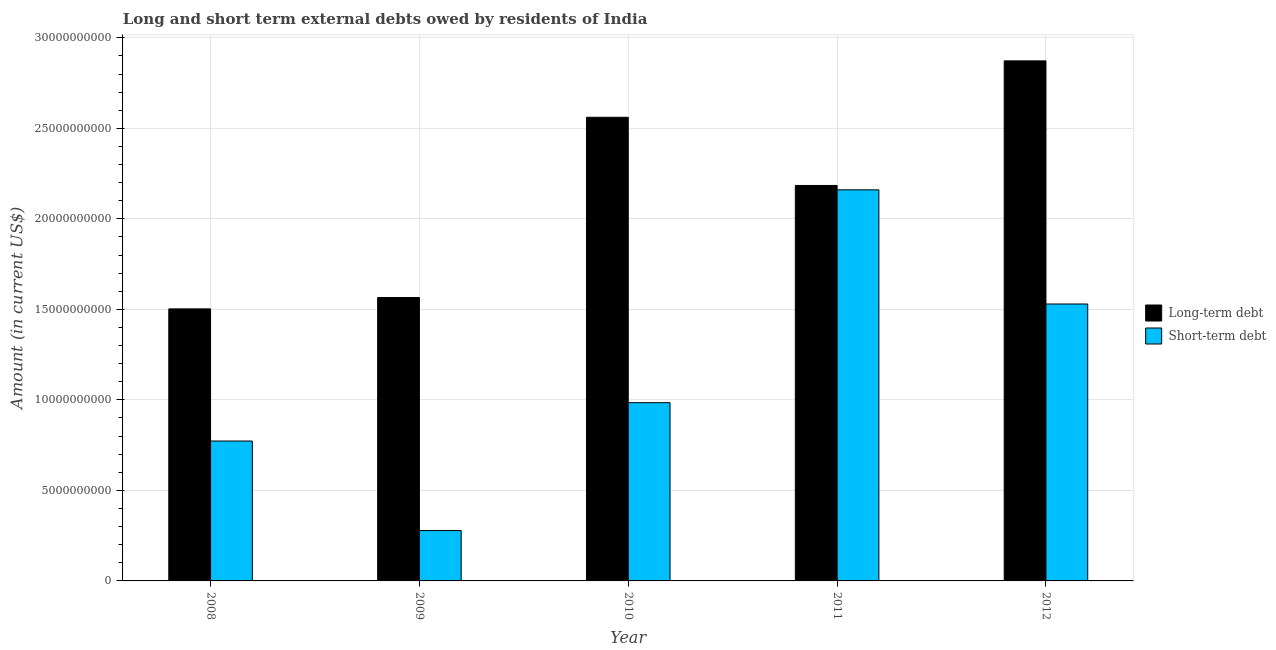How many groups of bars are there?
Your answer should be compact. 5. Are the number of bars on each tick of the X-axis equal?
Provide a short and direct response. Yes. How many bars are there on the 4th tick from the left?
Your response must be concise. 2. What is the label of the 2nd group of bars from the left?
Give a very brief answer. 2009. What is the long-term debts owed by residents in 2012?
Ensure brevity in your answer.  2.87e+1. Across all years, what is the maximum short-term debts owed by residents?
Your answer should be compact. 2.16e+1. Across all years, what is the minimum short-term debts owed by residents?
Your answer should be compact. 2.78e+09. What is the total short-term debts owed by residents in the graph?
Your response must be concise. 5.73e+1. What is the difference between the short-term debts owed by residents in 2008 and that in 2009?
Provide a succinct answer. 4.95e+09. What is the difference between the short-term debts owed by residents in 2011 and the long-term debts owed by residents in 2012?
Your response must be concise. 6.31e+09. What is the average short-term debts owed by residents per year?
Offer a terse response. 1.15e+1. What is the ratio of the short-term debts owed by residents in 2010 to that in 2012?
Keep it short and to the point. 0.64. Is the short-term debts owed by residents in 2009 less than that in 2012?
Your answer should be very brief. Yes. Is the difference between the short-term debts owed by residents in 2009 and 2010 greater than the difference between the long-term debts owed by residents in 2009 and 2010?
Offer a very short reply. No. What is the difference between the highest and the second highest long-term debts owed by residents?
Give a very brief answer. 3.12e+09. What is the difference between the highest and the lowest short-term debts owed by residents?
Ensure brevity in your answer.  1.88e+1. In how many years, is the long-term debts owed by residents greater than the average long-term debts owed by residents taken over all years?
Keep it short and to the point. 3. Is the sum of the short-term debts owed by residents in 2009 and 2010 greater than the maximum long-term debts owed by residents across all years?
Offer a very short reply. No. What does the 1st bar from the left in 2010 represents?
Give a very brief answer. Long-term debt. What does the 2nd bar from the right in 2010 represents?
Keep it short and to the point. Long-term debt. How many bars are there?
Your answer should be compact. 10. How many years are there in the graph?
Ensure brevity in your answer.  5. Where does the legend appear in the graph?
Your response must be concise. Center right. How many legend labels are there?
Ensure brevity in your answer.  2. What is the title of the graph?
Provide a succinct answer. Long and short term external debts owed by residents of India. What is the label or title of the X-axis?
Provide a short and direct response. Year. What is the Amount (in current US$) of Long-term debt in 2008?
Ensure brevity in your answer.  1.50e+1. What is the Amount (in current US$) of Short-term debt in 2008?
Your answer should be compact. 7.73e+09. What is the Amount (in current US$) of Long-term debt in 2009?
Offer a terse response. 1.57e+1. What is the Amount (in current US$) of Short-term debt in 2009?
Provide a succinct answer. 2.78e+09. What is the Amount (in current US$) in Long-term debt in 2010?
Your answer should be very brief. 2.56e+1. What is the Amount (in current US$) in Short-term debt in 2010?
Keep it short and to the point. 9.84e+09. What is the Amount (in current US$) in Long-term debt in 2011?
Keep it short and to the point. 2.18e+1. What is the Amount (in current US$) in Short-term debt in 2011?
Your response must be concise. 2.16e+1. What is the Amount (in current US$) of Long-term debt in 2012?
Give a very brief answer. 2.87e+1. What is the Amount (in current US$) of Short-term debt in 2012?
Your answer should be very brief. 1.53e+1. Across all years, what is the maximum Amount (in current US$) in Long-term debt?
Your response must be concise. 2.87e+1. Across all years, what is the maximum Amount (in current US$) of Short-term debt?
Provide a short and direct response. 2.16e+1. Across all years, what is the minimum Amount (in current US$) in Long-term debt?
Give a very brief answer. 1.50e+1. Across all years, what is the minimum Amount (in current US$) in Short-term debt?
Make the answer very short. 2.78e+09. What is the total Amount (in current US$) in Long-term debt in the graph?
Your response must be concise. 1.07e+11. What is the total Amount (in current US$) of Short-term debt in the graph?
Offer a terse response. 5.73e+1. What is the difference between the Amount (in current US$) in Long-term debt in 2008 and that in 2009?
Make the answer very short. -6.29e+08. What is the difference between the Amount (in current US$) of Short-term debt in 2008 and that in 2009?
Your answer should be compact. 4.95e+09. What is the difference between the Amount (in current US$) of Long-term debt in 2008 and that in 2010?
Ensure brevity in your answer.  -1.06e+1. What is the difference between the Amount (in current US$) in Short-term debt in 2008 and that in 2010?
Your response must be concise. -2.12e+09. What is the difference between the Amount (in current US$) in Long-term debt in 2008 and that in 2011?
Offer a very short reply. -6.82e+09. What is the difference between the Amount (in current US$) in Short-term debt in 2008 and that in 2011?
Your answer should be very brief. -1.39e+1. What is the difference between the Amount (in current US$) of Long-term debt in 2008 and that in 2012?
Offer a terse response. -1.37e+1. What is the difference between the Amount (in current US$) of Short-term debt in 2008 and that in 2012?
Give a very brief answer. -7.57e+09. What is the difference between the Amount (in current US$) of Long-term debt in 2009 and that in 2010?
Your answer should be compact. -9.96e+09. What is the difference between the Amount (in current US$) in Short-term debt in 2009 and that in 2010?
Provide a succinct answer. -7.06e+09. What is the difference between the Amount (in current US$) in Long-term debt in 2009 and that in 2011?
Ensure brevity in your answer.  -6.19e+09. What is the difference between the Amount (in current US$) in Short-term debt in 2009 and that in 2011?
Keep it short and to the point. -1.88e+1. What is the difference between the Amount (in current US$) in Long-term debt in 2009 and that in 2012?
Offer a very short reply. -1.31e+1. What is the difference between the Amount (in current US$) of Short-term debt in 2009 and that in 2012?
Your answer should be compact. -1.25e+1. What is the difference between the Amount (in current US$) in Long-term debt in 2010 and that in 2011?
Provide a short and direct response. 3.77e+09. What is the difference between the Amount (in current US$) in Short-term debt in 2010 and that in 2011?
Keep it short and to the point. -1.18e+1. What is the difference between the Amount (in current US$) of Long-term debt in 2010 and that in 2012?
Your answer should be compact. -3.12e+09. What is the difference between the Amount (in current US$) of Short-term debt in 2010 and that in 2012?
Your answer should be compact. -5.45e+09. What is the difference between the Amount (in current US$) in Long-term debt in 2011 and that in 2012?
Keep it short and to the point. -6.88e+09. What is the difference between the Amount (in current US$) of Short-term debt in 2011 and that in 2012?
Keep it short and to the point. 6.31e+09. What is the difference between the Amount (in current US$) of Long-term debt in 2008 and the Amount (in current US$) of Short-term debt in 2009?
Provide a short and direct response. 1.22e+1. What is the difference between the Amount (in current US$) in Long-term debt in 2008 and the Amount (in current US$) in Short-term debt in 2010?
Ensure brevity in your answer.  5.18e+09. What is the difference between the Amount (in current US$) of Long-term debt in 2008 and the Amount (in current US$) of Short-term debt in 2011?
Offer a very short reply. -6.58e+09. What is the difference between the Amount (in current US$) of Long-term debt in 2008 and the Amount (in current US$) of Short-term debt in 2012?
Ensure brevity in your answer.  -2.70e+08. What is the difference between the Amount (in current US$) of Long-term debt in 2009 and the Amount (in current US$) of Short-term debt in 2010?
Keep it short and to the point. 5.81e+09. What is the difference between the Amount (in current US$) in Long-term debt in 2009 and the Amount (in current US$) in Short-term debt in 2011?
Provide a succinct answer. -5.95e+09. What is the difference between the Amount (in current US$) in Long-term debt in 2009 and the Amount (in current US$) in Short-term debt in 2012?
Provide a succinct answer. 3.59e+08. What is the difference between the Amount (in current US$) of Long-term debt in 2010 and the Amount (in current US$) of Short-term debt in 2011?
Your answer should be very brief. 4.01e+09. What is the difference between the Amount (in current US$) in Long-term debt in 2010 and the Amount (in current US$) in Short-term debt in 2012?
Offer a very short reply. 1.03e+1. What is the difference between the Amount (in current US$) in Long-term debt in 2011 and the Amount (in current US$) in Short-term debt in 2012?
Your response must be concise. 6.55e+09. What is the average Amount (in current US$) of Long-term debt per year?
Your answer should be compact. 2.14e+1. What is the average Amount (in current US$) in Short-term debt per year?
Your response must be concise. 1.15e+1. In the year 2008, what is the difference between the Amount (in current US$) in Long-term debt and Amount (in current US$) in Short-term debt?
Provide a succinct answer. 7.30e+09. In the year 2009, what is the difference between the Amount (in current US$) of Long-term debt and Amount (in current US$) of Short-term debt?
Keep it short and to the point. 1.29e+1. In the year 2010, what is the difference between the Amount (in current US$) in Long-term debt and Amount (in current US$) in Short-term debt?
Your answer should be compact. 1.58e+1. In the year 2011, what is the difference between the Amount (in current US$) in Long-term debt and Amount (in current US$) in Short-term debt?
Provide a short and direct response. 2.41e+08. In the year 2012, what is the difference between the Amount (in current US$) of Long-term debt and Amount (in current US$) of Short-term debt?
Keep it short and to the point. 1.34e+1. What is the ratio of the Amount (in current US$) of Long-term debt in 2008 to that in 2009?
Ensure brevity in your answer.  0.96. What is the ratio of the Amount (in current US$) of Short-term debt in 2008 to that in 2009?
Keep it short and to the point. 2.78. What is the ratio of the Amount (in current US$) of Long-term debt in 2008 to that in 2010?
Keep it short and to the point. 0.59. What is the ratio of the Amount (in current US$) of Short-term debt in 2008 to that in 2010?
Your answer should be compact. 0.79. What is the ratio of the Amount (in current US$) in Long-term debt in 2008 to that in 2011?
Provide a short and direct response. 0.69. What is the ratio of the Amount (in current US$) of Short-term debt in 2008 to that in 2011?
Offer a terse response. 0.36. What is the ratio of the Amount (in current US$) in Long-term debt in 2008 to that in 2012?
Give a very brief answer. 0.52. What is the ratio of the Amount (in current US$) of Short-term debt in 2008 to that in 2012?
Provide a succinct answer. 0.51. What is the ratio of the Amount (in current US$) in Long-term debt in 2009 to that in 2010?
Provide a short and direct response. 0.61. What is the ratio of the Amount (in current US$) in Short-term debt in 2009 to that in 2010?
Offer a terse response. 0.28. What is the ratio of the Amount (in current US$) in Long-term debt in 2009 to that in 2011?
Your answer should be compact. 0.72. What is the ratio of the Amount (in current US$) of Short-term debt in 2009 to that in 2011?
Your answer should be very brief. 0.13. What is the ratio of the Amount (in current US$) of Long-term debt in 2009 to that in 2012?
Your response must be concise. 0.55. What is the ratio of the Amount (in current US$) of Short-term debt in 2009 to that in 2012?
Give a very brief answer. 0.18. What is the ratio of the Amount (in current US$) in Long-term debt in 2010 to that in 2011?
Your answer should be compact. 1.17. What is the ratio of the Amount (in current US$) of Short-term debt in 2010 to that in 2011?
Your answer should be very brief. 0.46. What is the ratio of the Amount (in current US$) of Long-term debt in 2010 to that in 2012?
Make the answer very short. 0.89. What is the ratio of the Amount (in current US$) of Short-term debt in 2010 to that in 2012?
Offer a terse response. 0.64. What is the ratio of the Amount (in current US$) of Long-term debt in 2011 to that in 2012?
Provide a succinct answer. 0.76. What is the ratio of the Amount (in current US$) of Short-term debt in 2011 to that in 2012?
Provide a short and direct response. 1.41. What is the difference between the highest and the second highest Amount (in current US$) in Long-term debt?
Your answer should be very brief. 3.12e+09. What is the difference between the highest and the second highest Amount (in current US$) of Short-term debt?
Ensure brevity in your answer.  6.31e+09. What is the difference between the highest and the lowest Amount (in current US$) in Long-term debt?
Ensure brevity in your answer.  1.37e+1. What is the difference between the highest and the lowest Amount (in current US$) in Short-term debt?
Provide a short and direct response. 1.88e+1. 